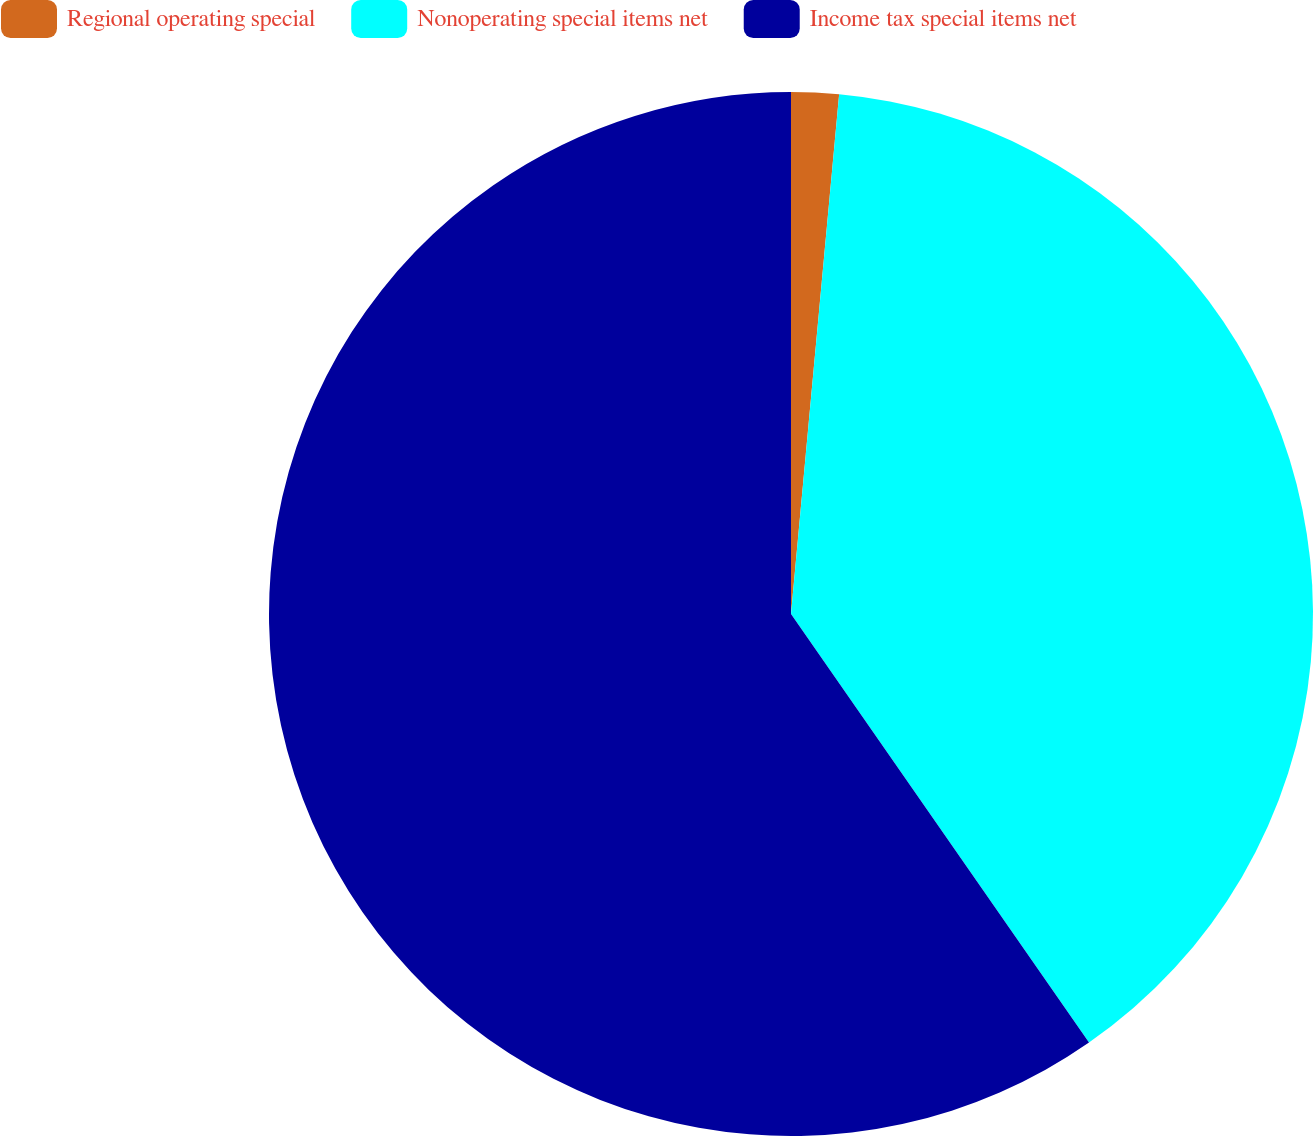Convert chart. <chart><loc_0><loc_0><loc_500><loc_500><pie_chart><fcel>Regional operating special<fcel>Nonoperating special items net<fcel>Income tax special items net<nl><fcel>1.47%<fcel>38.86%<fcel>59.67%<nl></chart> 